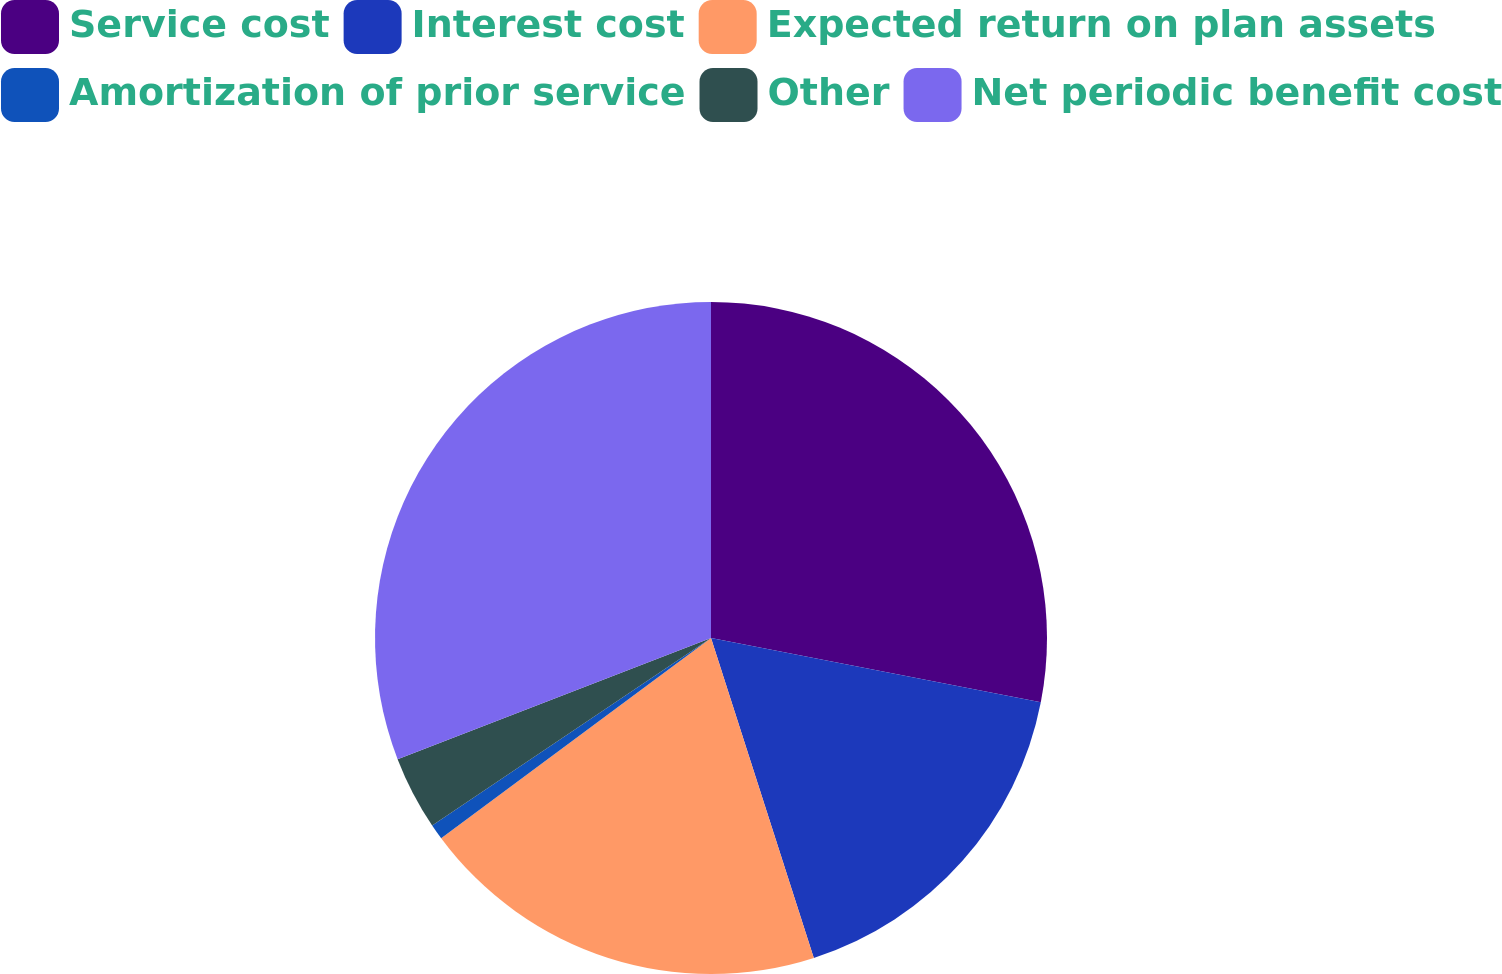Convert chart to OTSL. <chart><loc_0><loc_0><loc_500><loc_500><pie_chart><fcel>Service cost<fcel>Interest cost<fcel>Expected return on plan assets<fcel>Amortization of prior service<fcel>Other<fcel>Net periodic benefit cost<nl><fcel>28.06%<fcel>16.99%<fcel>19.79%<fcel>0.74%<fcel>3.55%<fcel>30.87%<nl></chart> 